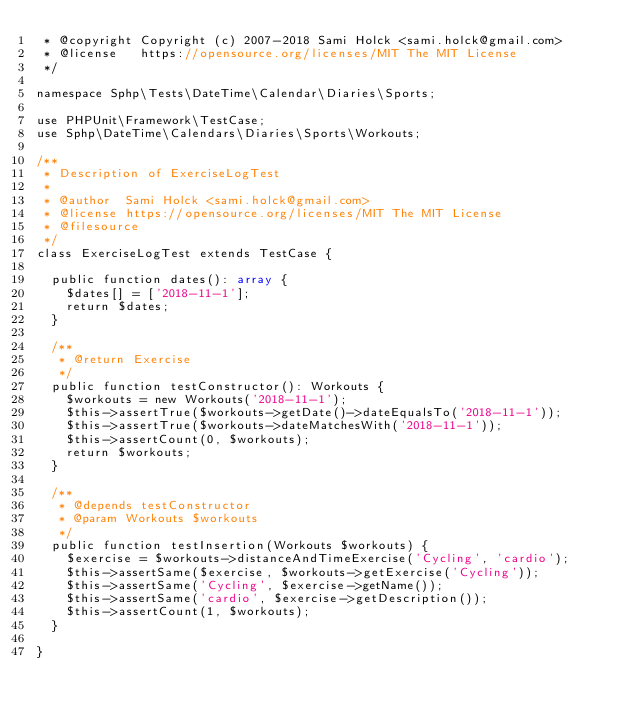<code> <loc_0><loc_0><loc_500><loc_500><_PHP_> * @copyright Copyright (c) 2007-2018 Sami Holck <sami.holck@gmail.com>
 * @license   https://opensource.org/licenses/MIT The MIT License
 */

namespace Sphp\Tests\DateTime\Calendar\Diaries\Sports;

use PHPUnit\Framework\TestCase;
use Sphp\DateTime\Calendars\Diaries\Sports\Workouts;

/**
 * Description of ExerciseLogTest
 *
 * @author  Sami Holck <sami.holck@gmail.com>
 * @license https://opensource.org/licenses/MIT The MIT License
 * @filesource
 */
class ExerciseLogTest extends TestCase {

  public function dates(): array {
    $dates[] = ['2018-11-1'];
    return $dates;
  }

  /**
   * @return Exercise
   */
  public function testConstructor(): Workouts {
    $workouts = new Workouts('2018-11-1');
    $this->assertTrue($workouts->getDate()->dateEqualsTo('2018-11-1'));
    $this->assertTrue($workouts->dateMatchesWith('2018-11-1'));
    $this->assertCount(0, $workouts);
    return $workouts;
  }

  /**
   * @depends testConstructor
   * @param Workouts $workouts
   */
  public function testInsertion(Workouts $workouts) {
    $exercise = $workouts->distanceAndTimeExercise('Cycling', 'cardio');
    $this->assertSame($exercise, $workouts->getExercise('Cycling'));
    $this->assertSame('Cycling', $exercise->getName());
    $this->assertSame('cardio', $exercise->getDescription());
    $this->assertCount(1, $workouts);
  }

}
</code> 